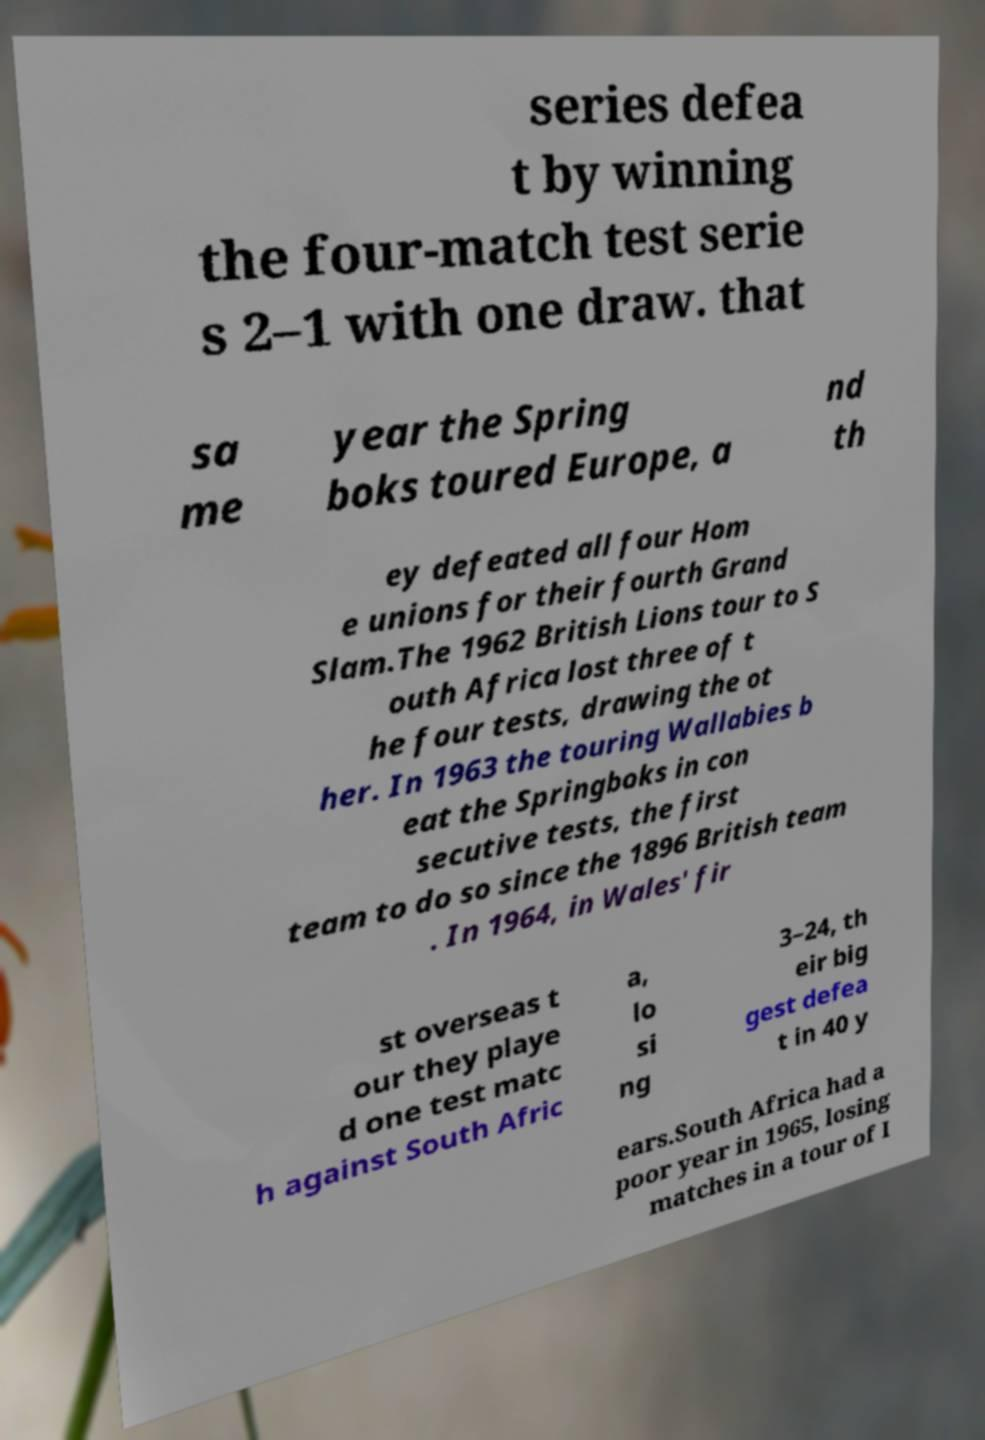Can you read and provide the text displayed in the image?This photo seems to have some interesting text. Can you extract and type it out for me? series defea t by winning the four-match test serie s 2–1 with one draw. that sa me year the Spring boks toured Europe, a nd th ey defeated all four Hom e unions for their fourth Grand Slam.The 1962 British Lions tour to S outh Africa lost three of t he four tests, drawing the ot her. In 1963 the touring Wallabies b eat the Springboks in con secutive tests, the first team to do so since the 1896 British team . In 1964, in Wales' fir st overseas t our they playe d one test matc h against South Afric a, lo si ng 3–24, th eir big gest defea t in 40 y ears.South Africa had a poor year in 1965, losing matches in a tour of I 